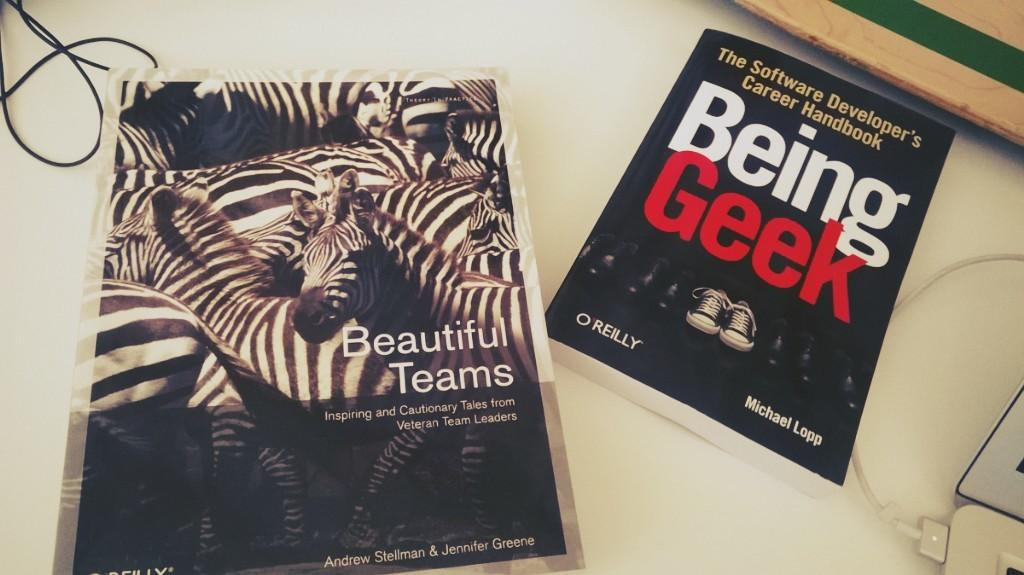<image>
Render a clear and concise summary of the photo. A book called Beautiful Teams has zebras on the cover. 